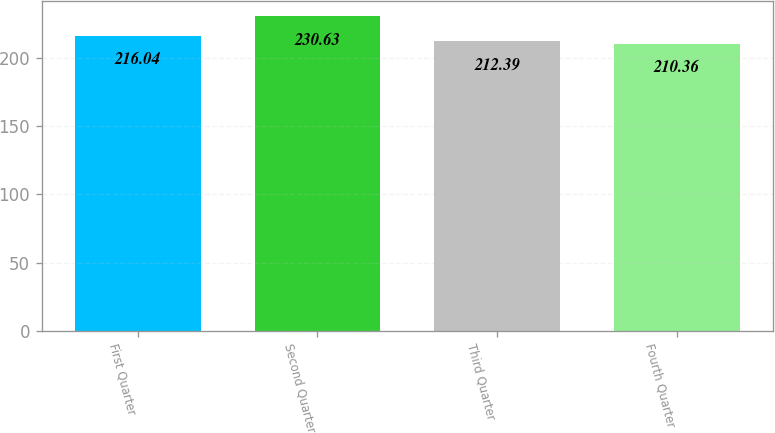Convert chart. <chart><loc_0><loc_0><loc_500><loc_500><bar_chart><fcel>First Quarter<fcel>Second Quarter<fcel>Third Quarter<fcel>Fourth Quarter<nl><fcel>216.04<fcel>230.63<fcel>212.39<fcel>210.36<nl></chart> 